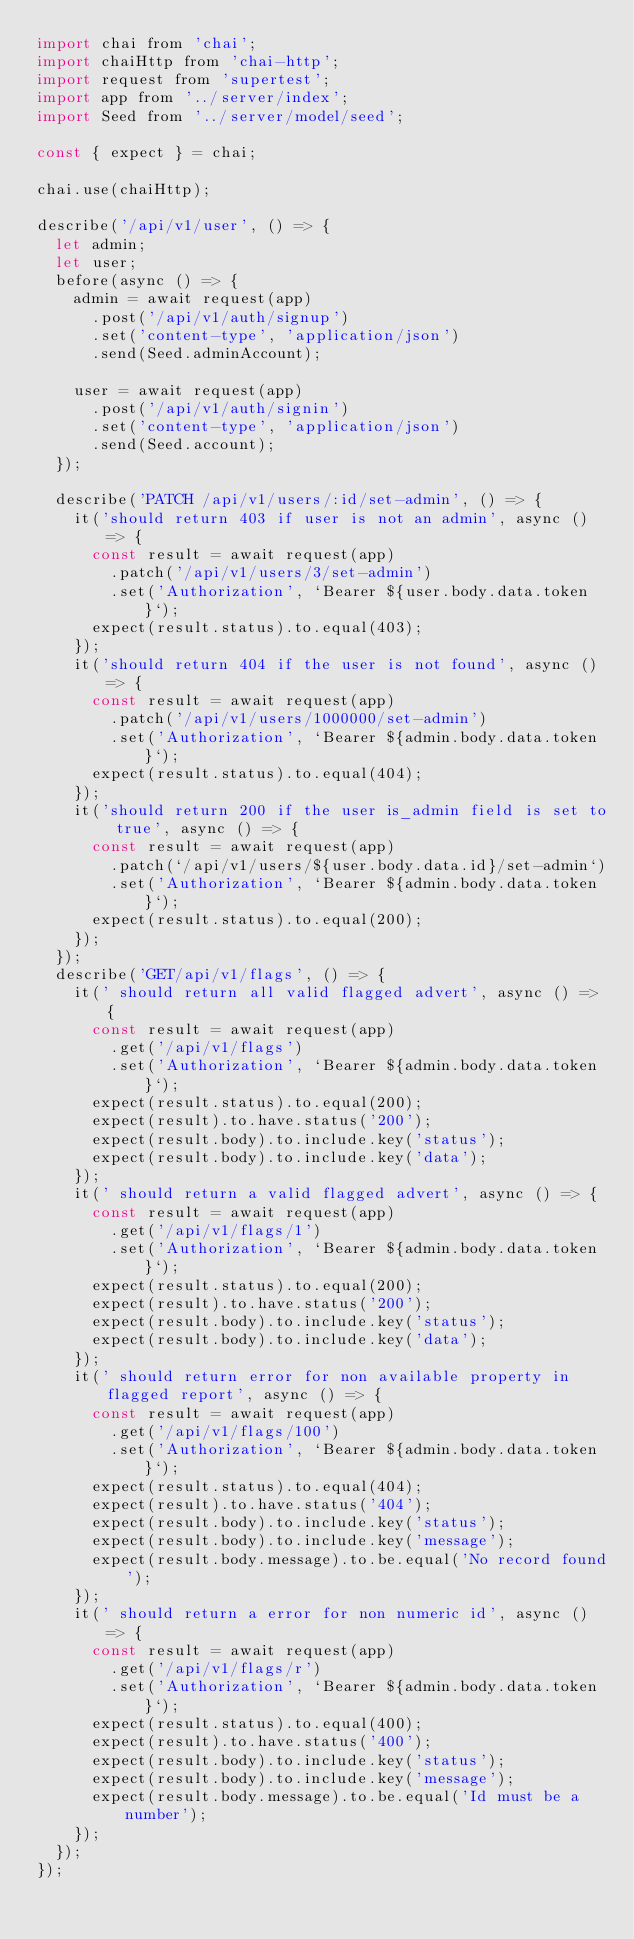<code> <loc_0><loc_0><loc_500><loc_500><_JavaScript_>import chai from 'chai';
import chaiHttp from 'chai-http';
import request from 'supertest';
import app from '../server/index';
import Seed from '../server/model/seed';

const { expect } = chai;

chai.use(chaiHttp);

describe('/api/v1/user', () => {
  let admin;
  let user;
  before(async () => {
    admin = await request(app)
      .post('/api/v1/auth/signup')
      .set('content-type', 'application/json')
      .send(Seed.adminAccount);

    user = await request(app)
      .post('/api/v1/auth/signin')
      .set('content-type', 'application/json')
      .send(Seed.account);
  });

  describe('PATCH /api/v1/users/:id/set-admin', () => {
    it('should return 403 if user is not an admin', async () => {
      const result = await request(app)
        .patch('/api/v1/users/3/set-admin')
        .set('Authorization', `Bearer ${user.body.data.token}`);
      expect(result.status).to.equal(403);
    });
    it('should return 404 if the user is not found', async () => {
      const result = await request(app)
        .patch('/api/v1/users/1000000/set-admin')
        .set('Authorization', `Bearer ${admin.body.data.token}`);
      expect(result.status).to.equal(404);
    });
    it('should return 200 if the user is_admin field is set to true', async () => {
      const result = await request(app)
        .patch(`/api/v1/users/${user.body.data.id}/set-admin`)
        .set('Authorization', `Bearer ${admin.body.data.token}`);
      expect(result.status).to.equal(200);
    });
  });
  describe('GET/api/v1/flags', () => {
    it(' should return all valid flagged advert', async () => {
      const result = await request(app)
        .get('/api/v1/flags')
        .set('Authorization', `Bearer ${admin.body.data.token}`);
      expect(result.status).to.equal(200);
      expect(result).to.have.status('200');
      expect(result.body).to.include.key('status');
      expect(result.body).to.include.key('data');
    });
    it(' should return a valid flagged advert', async () => {
      const result = await request(app)
        .get('/api/v1/flags/1')
        .set('Authorization', `Bearer ${admin.body.data.token}`);
      expect(result.status).to.equal(200);
      expect(result).to.have.status('200');
      expect(result.body).to.include.key('status');
      expect(result.body).to.include.key('data');
    });
    it(' should return error for non available property in flagged report', async () => {
      const result = await request(app)
        .get('/api/v1/flags/100')
        .set('Authorization', `Bearer ${admin.body.data.token}`);
      expect(result.status).to.equal(404);
      expect(result).to.have.status('404');
      expect(result.body).to.include.key('status');
      expect(result.body).to.include.key('message');
      expect(result.body.message).to.be.equal('No record found');
    });
    it(' should return a error for non numeric id', async () => {
      const result = await request(app)
        .get('/api/v1/flags/r')
        .set('Authorization', `Bearer ${admin.body.data.token}`);
      expect(result.status).to.equal(400);
      expect(result).to.have.status('400');
      expect(result.body).to.include.key('status');
      expect(result.body).to.include.key('message');
      expect(result.body.message).to.be.equal('Id must be a number');
    });
  });
});
</code> 